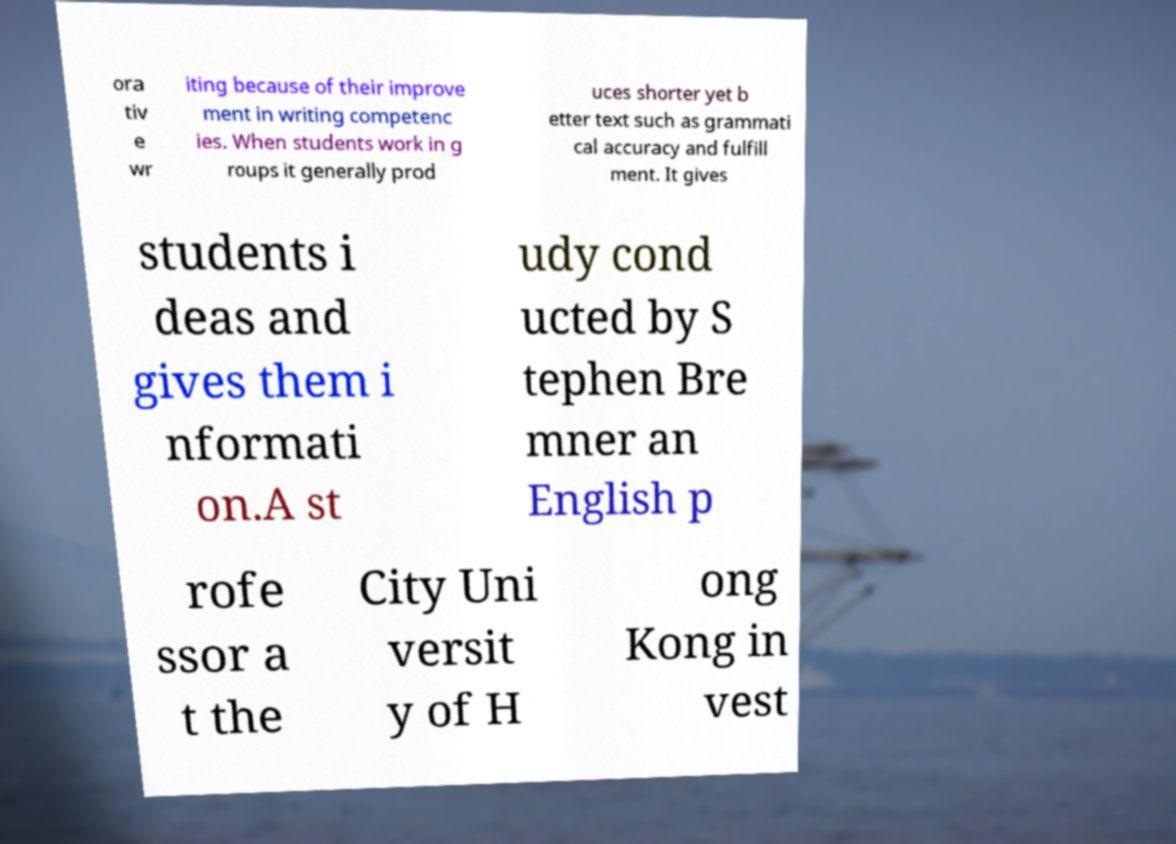What messages or text are displayed in this image? I need them in a readable, typed format. ora tiv e wr iting because of their improve ment in writing competenc ies. When students work in g roups it generally prod uces shorter yet b etter text such as grammati cal accuracy and fulfill ment. It gives students i deas and gives them i nformati on.A st udy cond ucted by S tephen Bre mner an English p rofe ssor a t the City Uni versit y of H ong Kong in vest 